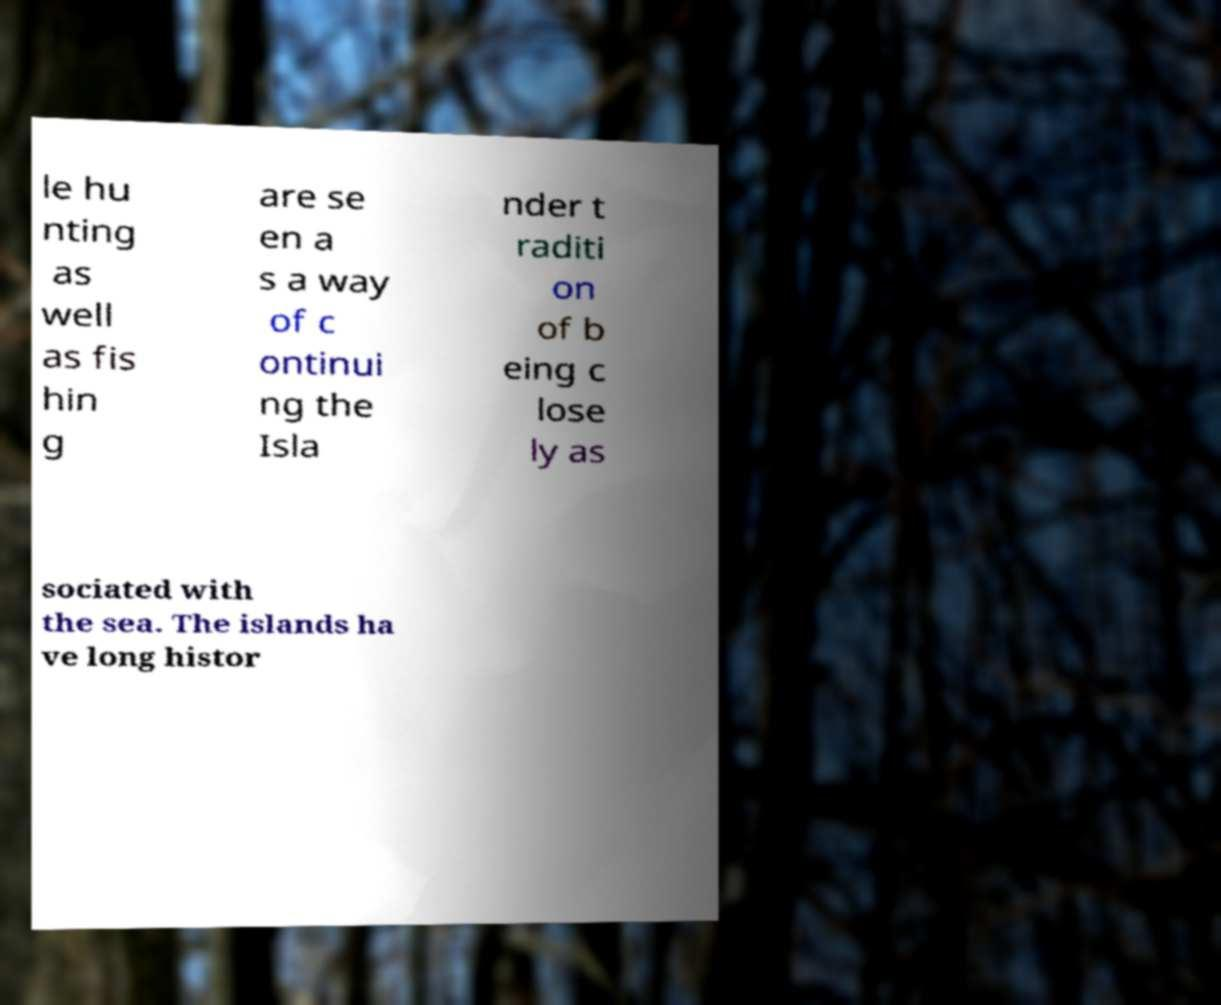Can you accurately transcribe the text from the provided image for me? le hu nting as well as fis hin g are se en a s a way of c ontinui ng the Isla nder t raditi on of b eing c lose ly as sociated with the sea. The islands ha ve long histor 